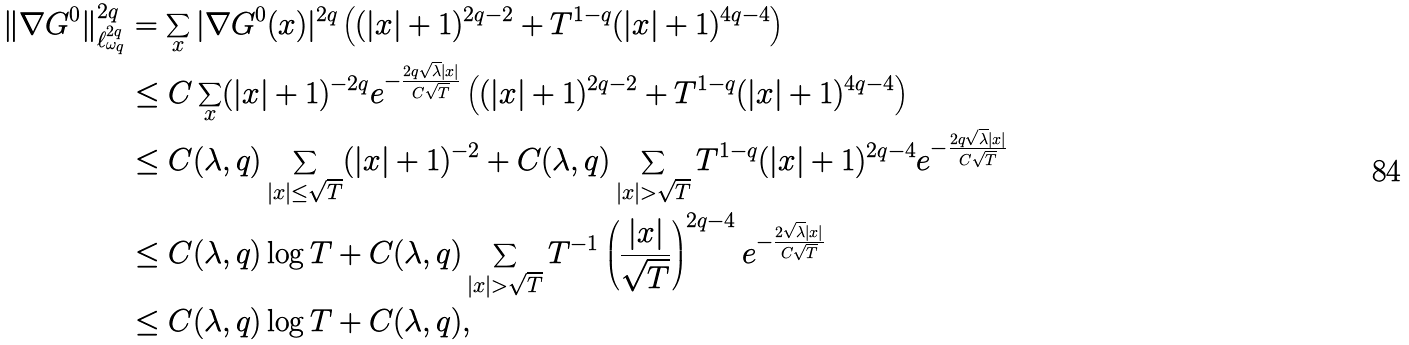Convert formula to latex. <formula><loc_0><loc_0><loc_500><loc_500>\| \nabla G ^ { 0 } \| _ { \ell ^ { 2 q } _ { \omega _ { q } } } ^ { 2 q } & = \sum _ { x } | \nabla G ^ { 0 } ( x ) | ^ { 2 q } \left ( ( | x | + 1 ) ^ { 2 q - 2 } + T ^ { 1 - q } ( | x | + 1 ) ^ { 4 q - 4 } \right ) \\ & \leq C \sum _ { x } ( | x | + 1 ) ^ { - 2 q } e ^ { - \frac { 2 q { \sqrt { \lambda } } | x | } { C \sqrt { T } } } \left ( ( | x | + 1 ) ^ { 2 q - 2 } + T ^ { 1 - q } ( | x | + 1 ) ^ { 4 q - 4 } \right ) \\ & \leq C ( \lambda , q ) \sum _ { | x | \leq \sqrt { T } } ( | x | + 1 ) ^ { - 2 } + C ( \lambda , q ) \sum _ { | x | > \sqrt { T } } { T } ^ { 1 - q } ( | x | + 1 ) ^ { 2 q - 4 } e ^ { - \frac { 2 q { \sqrt { \lambda } } | x | } { C \sqrt { T } } } \\ & \leq C ( \lambda , q ) \log T + C ( \lambda , q ) \sum _ { | x | > \sqrt { T } } { T } ^ { - 1 } \left ( { \frac { | x | } { \sqrt { T } } } \right ) ^ { 2 q - 4 } e ^ { - \frac { 2 { \sqrt { \lambda } } | x | } { C \sqrt { T } } } \\ & \leq C ( \lambda , q ) \log T + C ( \lambda , q ) ,</formula> 